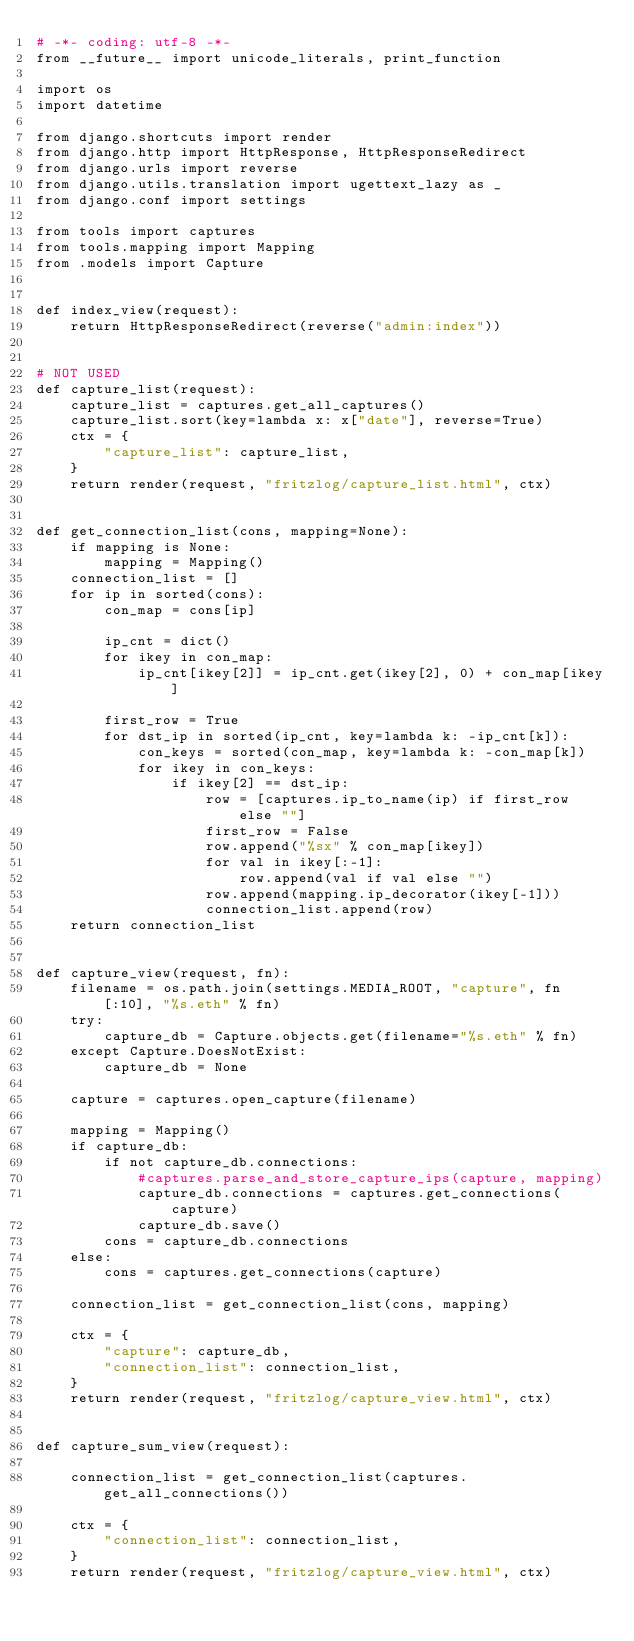<code> <loc_0><loc_0><loc_500><loc_500><_Python_># -*- coding: utf-8 -*-
from __future__ import unicode_literals, print_function

import os
import datetime

from django.shortcuts import render
from django.http import HttpResponse, HttpResponseRedirect
from django.urls import reverse
from django.utils.translation import ugettext_lazy as _
from django.conf import settings

from tools import captures
from tools.mapping import Mapping
from .models import Capture


def index_view(request):
    return HttpResponseRedirect(reverse("admin:index"))


# NOT USED
def capture_list(request):
    capture_list = captures.get_all_captures()
    capture_list.sort(key=lambda x: x["date"], reverse=True)
    ctx = {
        "capture_list": capture_list,
    }
    return render(request, "fritzlog/capture_list.html", ctx)


def get_connection_list(cons, mapping=None):
    if mapping is None:
        mapping = Mapping()
    connection_list = []
    for ip in sorted(cons):
        con_map = cons[ip]

        ip_cnt = dict()
        for ikey in con_map:
            ip_cnt[ikey[2]] = ip_cnt.get(ikey[2], 0) + con_map[ikey]

        first_row = True
        for dst_ip in sorted(ip_cnt, key=lambda k: -ip_cnt[k]):
            con_keys = sorted(con_map, key=lambda k: -con_map[k])
            for ikey in con_keys:
                if ikey[2] == dst_ip:
                    row = [captures.ip_to_name(ip) if first_row else ""]
                    first_row = False
                    row.append("%sx" % con_map[ikey])
                    for val in ikey[:-1]:
                        row.append(val if val else "")
                    row.append(mapping.ip_decorator(ikey[-1]))
                    connection_list.append(row)
    return connection_list


def capture_view(request, fn):
    filename = os.path.join(settings.MEDIA_ROOT, "capture", fn[:10], "%s.eth" % fn)
    try:
        capture_db = Capture.objects.get(filename="%s.eth" % fn)
    except Capture.DoesNotExist:
        capture_db = None

    capture = captures.open_capture(filename)

    mapping = Mapping()
    if capture_db:
        if not capture_db.connections:
            #captures.parse_and_store_capture_ips(capture, mapping)
            capture_db.connections = captures.get_connections(capture)
            capture_db.save()
        cons = capture_db.connections
    else:
        cons = captures.get_connections(capture)

    connection_list = get_connection_list(cons, mapping)

    ctx = {
        "capture": capture_db,
        "connection_list": connection_list,
    }
    return render(request, "fritzlog/capture_view.html", ctx)


def capture_sum_view(request):

    connection_list = get_connection_list(captures.get_all_connections())

    ctx = {
        "connection_list": connection_list,
    }
    return render(request, "fritzlog/capture_view.html", ctx)
</code> 